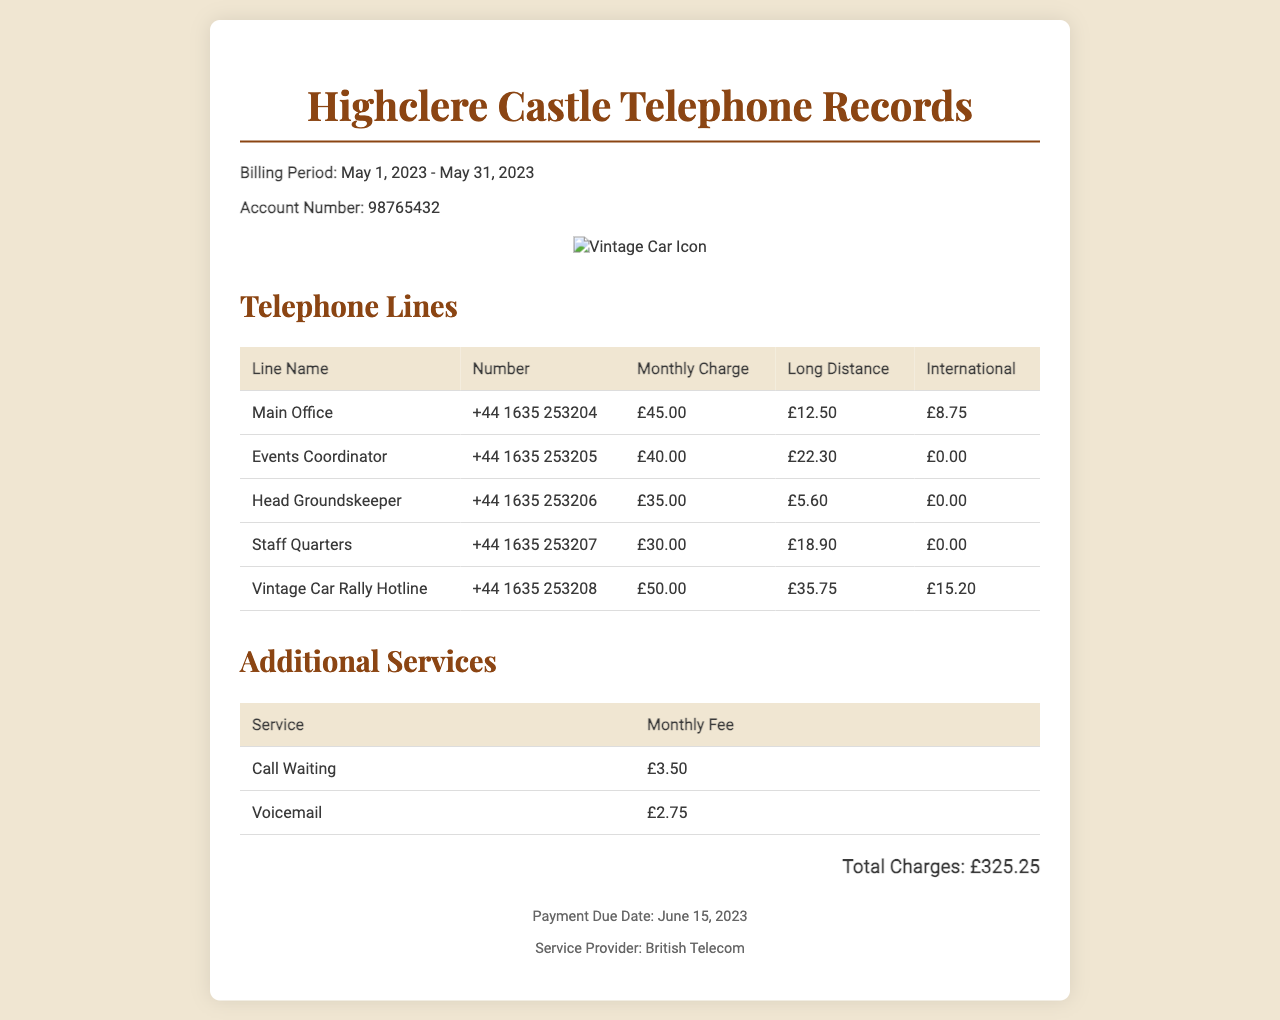What is the billing period? The billing period is explicitly stated at the beginning of the document, indicating the timeframe of the charges.
Answer: May 1, 2023 - May 31, 2023 What is the account number? The document includes the account number which is essential for identification of the billing statement.
Answer: 98765432 How much is the monthly charge for the Vintage Car Rally Hotline? The table lists the monthly charges for different lines and shows the charge for the specific line.
Answer: £50.00 What is the total amount of long-distance charges? The long-distance charges are summed from all lines, providing insight into communication expenses.
Answer: £94.05 Which line has the highest monthly charge? By reviewing the "Monthly Charge" column in the table, you can identify the line with the highest fee.
Answer: Vintage Car Rally Hotline What is the fee for call waiting? The document mentions additional services along with their respective fees, indicating the cost for this service.
Answer: £3.50 How many telephone lines are listed in the document? Counting the lines in the table reveals the total number of telephone lines served on the estate.
Answer: 5 What is the payment due date? The payment due date is clearly stated in the footer, which is essential for timely payments.
Answer: June 15, 2023 Is there a charge for international calls on the Events Coordinator line? The charge for international calls is noted in the respective column for that line, showing if there's a charge.
Answer: £0.00 